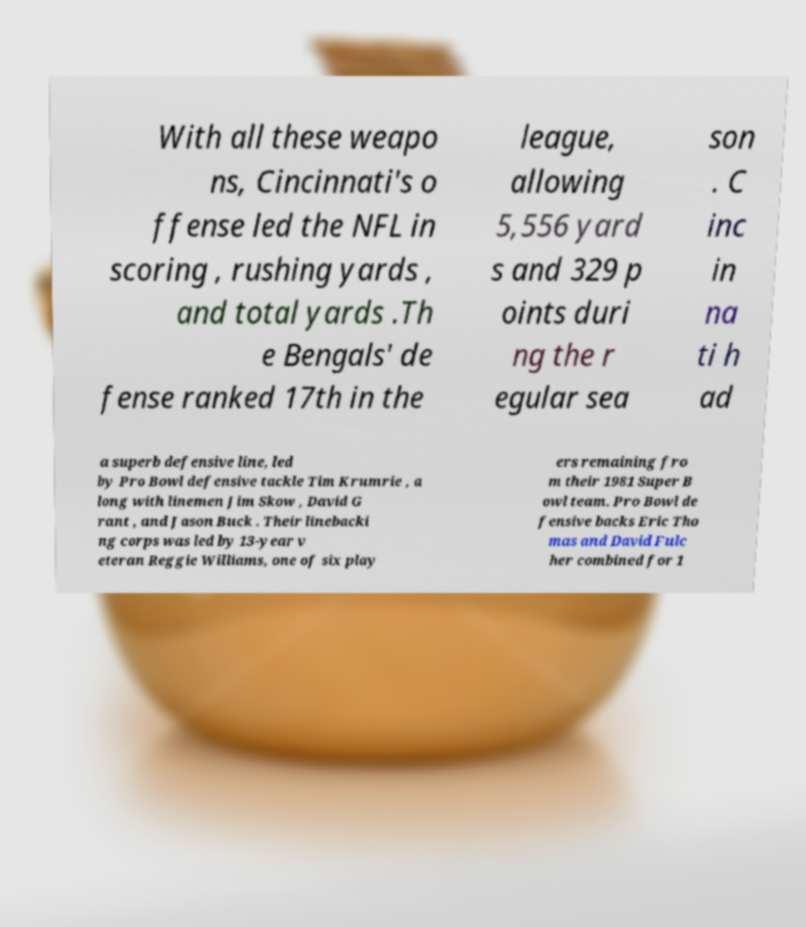What messages or text are displayed in this image? I need them in a readable, typed format. With all these weapo ns, Cincinnati's o ffense led the NFL in scoring , rushing yards , and total yards .Th e Bengals' de fense ranked 17th in the league, allowing 5,556 yard s and 329 p oints duri ng the r egular sea son . C inc in na ti h ad a superb defensive line, led by Pro Bowl defensive tackle Tim Krumrie , a long with linemen Jim Skow , David G rant , and Jason Buck . Their linebacki ng corps was led by 13-year v eteran Reggie Williams, one of six play ers remaining fro m their 1981 Super B owl team. Pro Bowl de fensive backs Eric Tho mas and David Fulc her combined for 1 